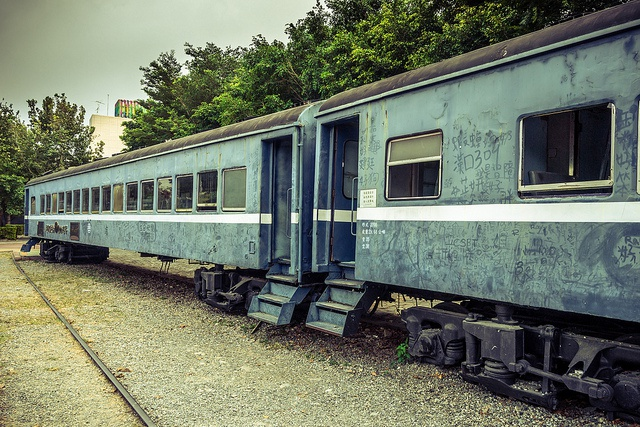Describe the objects in this image and their specific colors. I can see a train in gray, black, and darkgray tones in this image. 